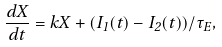Convert formula to latex. <formula><loc_0><loc_0><loc_500><loc_500>\frac { d X } { d t } = k X + ( I _ { 1 } ( t ) - I _ { 2 } ( t ) ) / \tau _ { E } ,</formula> 